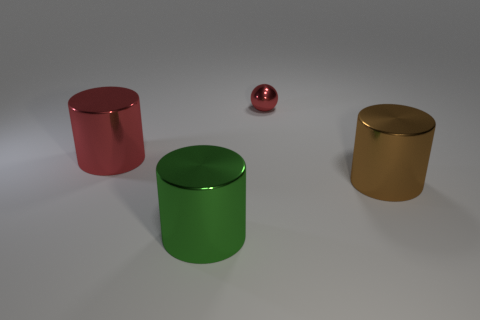Subtract all red cylinders. How many cylinders are left? 2 Add 1 big brown objects. How many objects exist? 5 Subtract all brown cylinders. How many cylinders are left? 2 Subtract all spheres. How many objects are left? 3 Subtract all brown cylinders. Subtract all cyan cubes. How many cylinders are left? 2 Subtract all red blocks. How many red cylinders are left? 1 Subtract all tiny gray things. Subtract all brown objects. How many objects are left? 3 Add 4 large things. How many large things are left? 7 Add 2 green things. How many green things exist? 3 Subtract 0 red blocks. How many objects are left? 4 